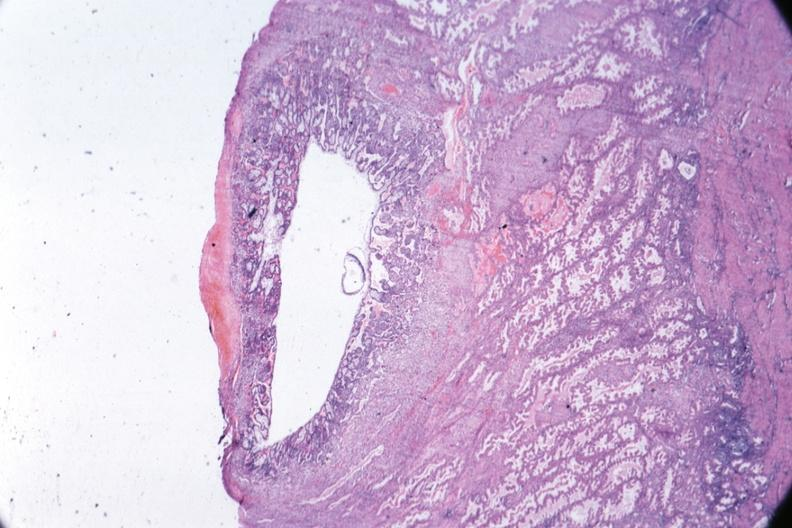s metastatic carcinoma oat cell present?
Answer the question using a single word or phrase. No 